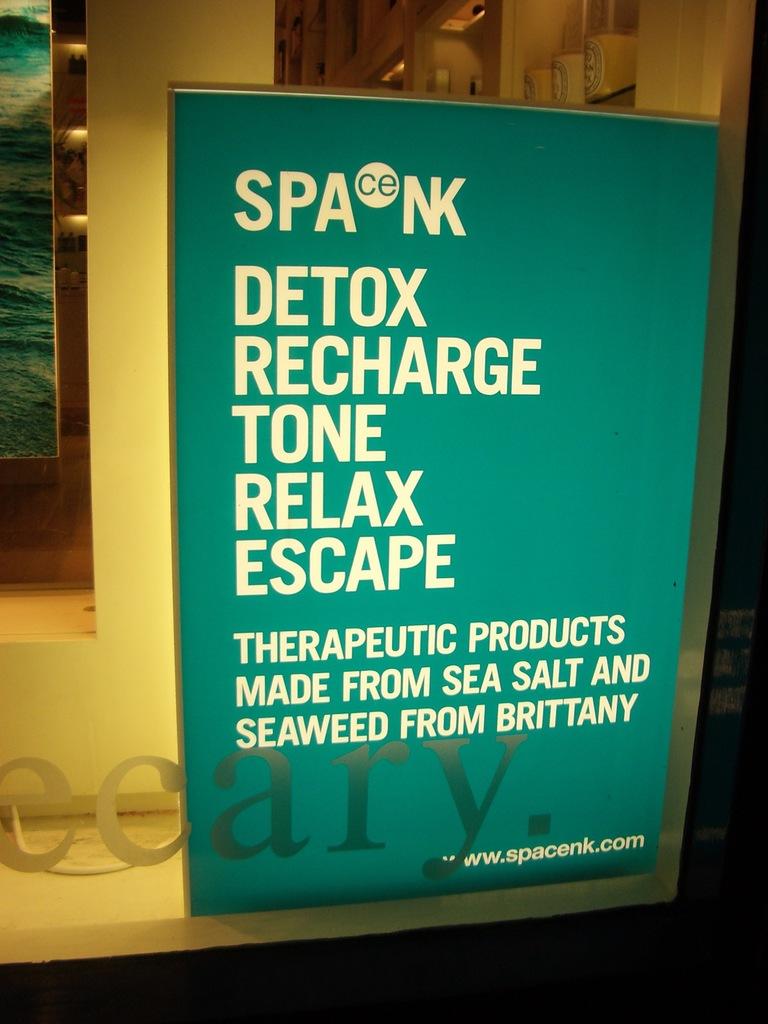What are the therapeutic products advertised made of?
Offer a very short reply. Sea salt and seaweed. What does the ad say to do?
Keep it short and to the point. Detox recharge tone relax escape. 